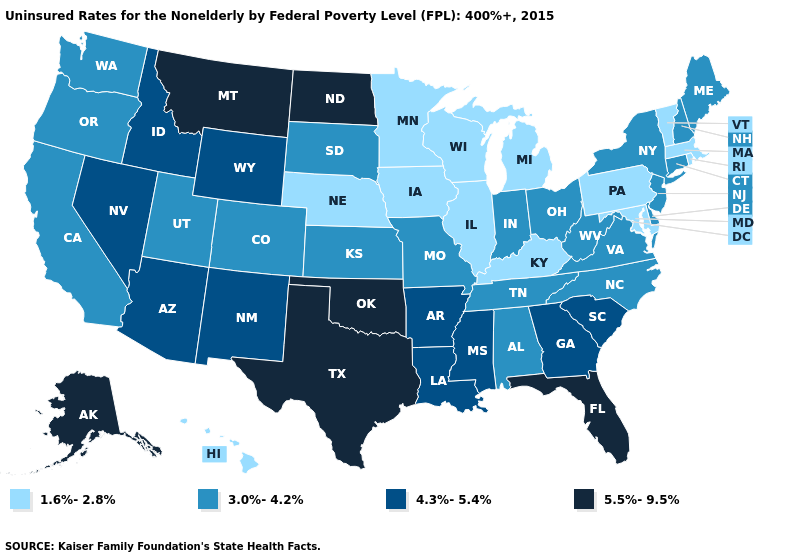Name the states that have a value in the range 1.6%-2.8%?
Write a very short answer. Hawaii, Illinois, Iowa, Kentucky, Maryland, Massachusetts, Michigan, Minnesota, Nebraska, Pennsylvania, Rhode Island, Vermont, Wisconsin. What is the value of Kansas?
Keep it brief. 3.0%-4.2%. Name the states that have a value in the range 3.0%-4.2%?
Give a very brief answer. Alabama, California, Colorado, Connecticut, Delaware, Indiana, Kansas, Maine, Missouri, New Hampshire, New Jersey, New York, North Carolina, Ohio, Oregon, South Dakota, Tennessee, Utah, Virginia, Washington, West Virginia. Name the states that have a value in the range 4.3%-5.4%?
Keep it brief. Arizona, Arkansas, Georgia, Idaho, Louisiana, Mississippi, Nevada, New Mexico, South Carolina, Wyoming. Which states have the lowest value in the USA?
Keep it brief. Hawaii, Illinois, Iowa, Kentucky, Maryland, Massachusetts, Michigan, Minnesota, Nebraska, Pennsylvania, Rhode Island, Vermont, Wisconsin. What is the lowest value in the MidWest?
Short answer required. 1.6%-2.8%. What is the highest value in the South ?
Short answer required. 5.5%-9.5%. Does Pennsylvania have the lowest value in the USA?
Be succinct. Yes. Which states hav the highest value in the South?
Answer briefly. Florida, Oklahoma, Texas. What is the highest value in the South ?
Answer briefly. 5.5%-9.5%. Does the first symbol in the legend represent the smallest category?
Answer briefly. Yes. Which states have the highest value in the USA?
Keep it brief. Alaska, Florida, Montana, North Dakota, Oklahoma, Texas. What is the value of Arkansas?
Keep it brief. 4.3%-5.4%. What is the value of West Virginia?
Write a very short answer. 3.0%-4.2%. Among the states that border South Dakota , which have the highest value?
Write a very short answer. Montana, North Dakota. 